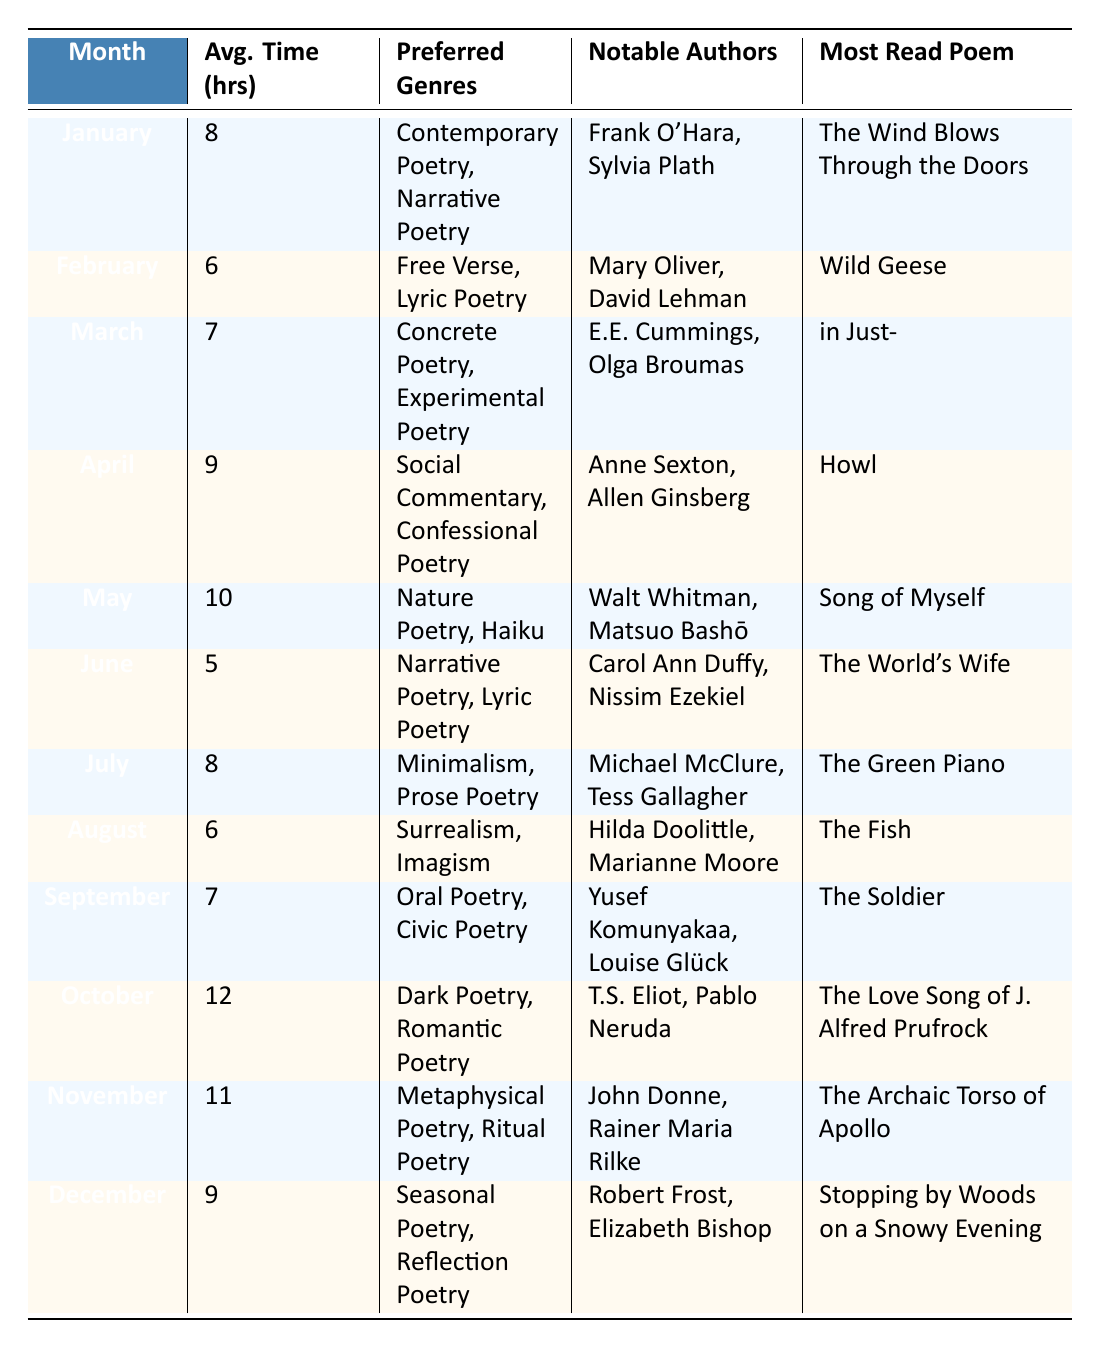What month had the most average time spent reading poetry? The table shows the average time spent reading poetry for each month. By inspecting the average hours column, it's evident that October has the highest value of 12 hours.
Answer: October Which poetry genre was preferred in June? In the June row of the table, the preferred genres listed are Narrative Poetry and Lyric Poetry.
Answer: Narrative Poetry, Lyric Poetry How many hours on average did readers spend on poetry in the month of May compared to July? The average hours for May is 10 and for July is 8. To find the difference, subtract the July average from the May average: 10 - 8 = 2.
Answer: 2 Is "The Wind Blows Through the Doors" the most read poem in February? The most read poem listed for February is "Wild Geese." Since this does not match "The Wind Blows Through the Doors," the statement is false.
Answer: No What is the total average reading time for the months of January and November? The average reading times for January and November are 8 hours and 11 hours, respectively. Adding these together gives: 8 + 11 = 19 hours.
Answer: 19 Which notable authors are associated with the poem "Howl"? Referring to the April row, the notable authors listed are Anne Sexton and Allen Ginsberg.
Answer: Anne Sexton, Allen Ginsberg During which month did readers show a preference for Dark Poetry? In the table, the genre of Dark Poetry is associated with the month of October, as that is where it is listed as a preferred genre.
Answer: October Is the most read poem in March a free verse? The most read poem in March is "in Just-". Since it is classified under Concrete Poetry and Experimental Poetry, the statement is false.
Answer: No What is the average reading time for the months of April and December? The average reading times for April and December are 9 hours and 12 hours, respectively. The total is: 9 + 12 = 21 hours. To find the average, divide 21 by the number of months (2): 21/2 = 10.5 hours.
Answer: 10.5 